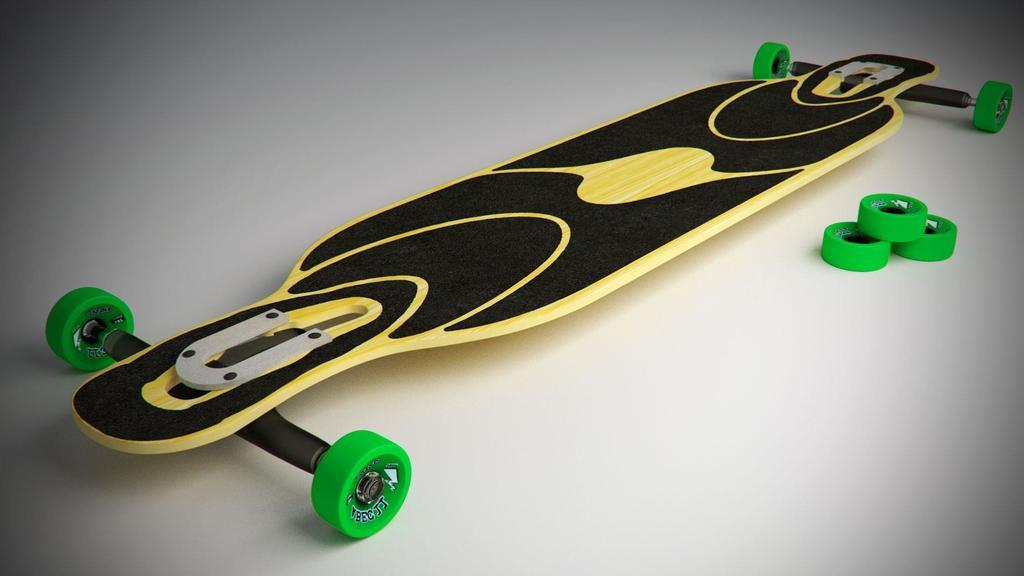What is the main object in the picture? There is a skateboard in the picture. Can you describe the skateboard's wheels? Skateboard wheels are visible on the right side of the picture. What type of nut is being used to secure the skateboard's form in the image? There is no nut or form visible in the image; it only features a skateboard and its wheels. 